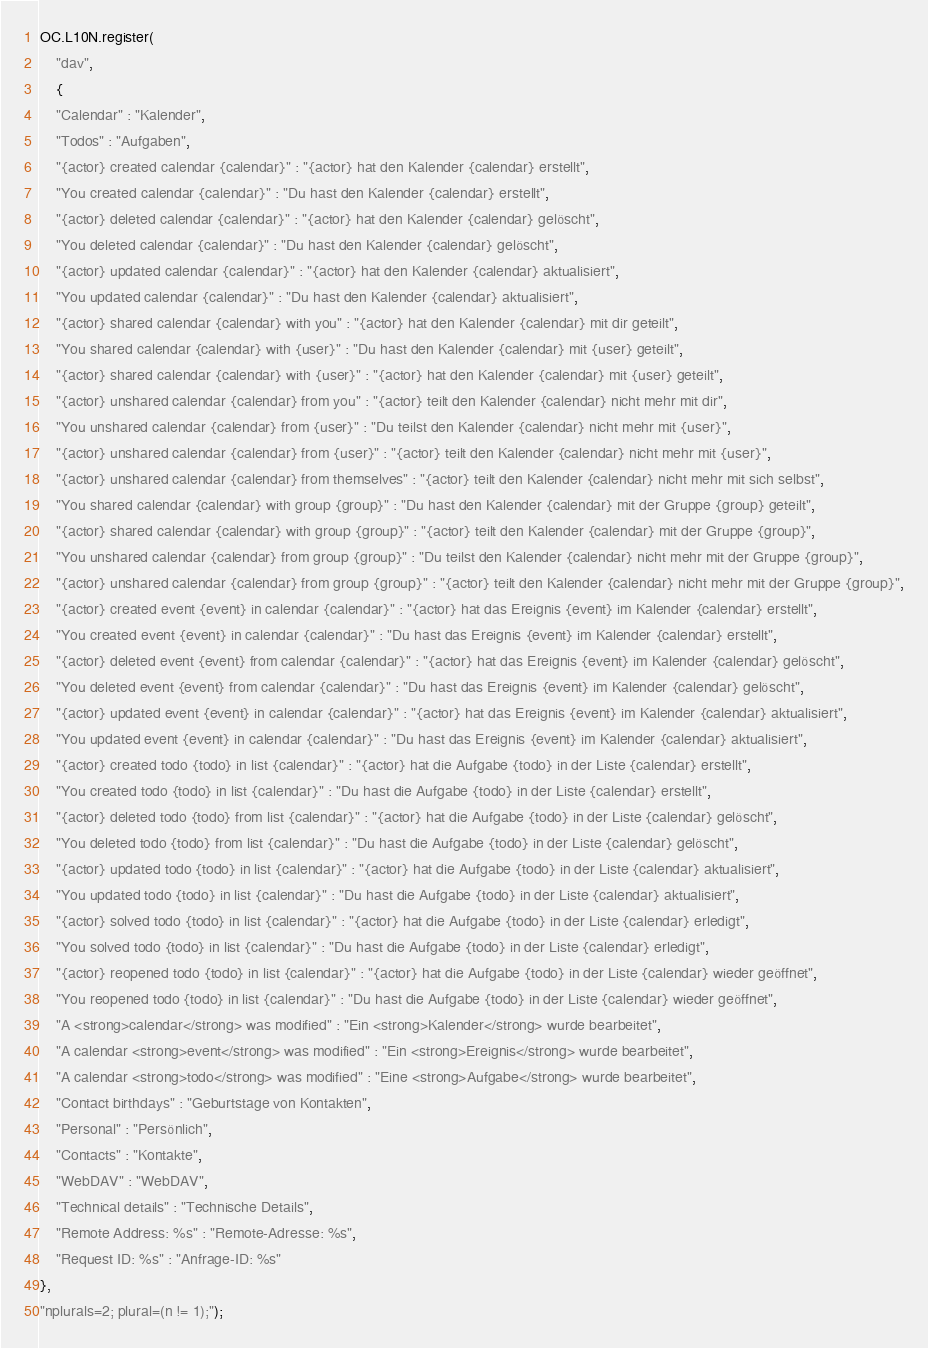<code> <loc_0><loc_0><loc_500><loc_500><_JavaScript_>OC.L10N.register(
    "dav",
    {
    "Calendar" : "Kalender",
    "Todos" : "Aufgaben",
    "{actor} created calendar {calendar}" : "{actor} hat den Kalender {calendar} erstellt",
    "You created calendar {calendar}" : "Du hast den Kalender {calendar} erstellt",
    "{actor} deleted calendar {calendar}" : "{actor} hat den Kalender {calendar} gelöscht",
    "You deleted calendar {calendar}" : "Du hast den Kalender {calendar} gelöscht",
    "{actor} updated calendar {calendar}" : "{actor} hat den Kalender {calendar} aktualisiert",
    "You updated calendar {calendar}" : "Du hast den Kalender {calendar} aktualisiert",
    "{actor} shared calendar {calendar} with you" : "{actor} hat den Kalender {calendar} mit dir geteilt",
    "You shared calendar {calendar} with {user}" : "Du hast den Kalender {calendar} mit {user} geteilt",
    "{actor} shared calendar {calendar} with {user}" : "{actor} hat den Kalender {calendar} mit {user} geteilt",
    "{actor} unshared calendar {calendar} from you" : "{actor} teilt den Kalender {calendar} nicht mehr mit dir",
    "You unshared calendar {calendar} from {user}" : "Du teilst den Kalender {calendar} nicht mehr mit {user}",
    "{actor} unshared calendar {calendar} from {user}" : "{actor} teilt den Kalender {calendar} nicht mehr mit {user}",
    "{actor} unshared calendar {calendar} from themselves" : "{actor} teilt den Kalender {calendar} nicht mehr mit sich selbst",
    "You shared calendar {calendar} with group {group}" : "Du hast den Kalender {calendar} mit der Gruppe {group} geteilt",
    "{actor} shared calendar {calendar} with group {group}" : "{actor} teilt den Kalender {calendar} mit der Gruppe {group}",
    "You unshared calendar {calendar} from group {group}" : "Du teilst den Kalender {calendar} nicht mehr mit der Gruppe {group}",
    "{actor} unshared calendar {calendar} from group {group}" : "{actor} teilt den Kalender {calendar} nicht mehr mit der Gruppe {group}",
    "{actor} created event {event} in calendar {calendar}" : "{actor} hat das Ereignis {event} im Kalender {calendar} erstellt",
    "You created event {event} in calendar {calendar}" : "Du hast das Ereignis {event} im Kalender {calendar} erstellt",
    "{actor} deleted event {event} from calendar {calendar}" : "{actor} hat das Ereignis {event} im Kalender {calendar} gelöscht",
    "You deleted event {event} from calendar {calendar}" : "Du hast das Ereignis {event} im Kalender {calendar} gelöscht",
    "{actor} updated event {event} in calendar {calendar}" : "{actor} hat das Ereignis {event} im Kalender {calendar} aktualisiert",
    "You updated event {event} in calendar {calendar}" : "Du hast das Ereignis {event} im Kalender {calendar} aktualisiert",
    "{actor} created todo {todo} in list {calendar}" : "{actor} hat die Aufgabe {todo} in der Liste {calendar} erstellt",
    "You created todo {todo} in list {calendar}" : "Du hast die Aufgabe {todo} in der Liste {calendar} erstellt",
    "{actor} deleted todo {todo} from list {calendar}" : "{actor} hat die Aufgabe {todo} in der Liste {calendar} gelöscht",
    "You deleted todo {todo} from list {calendar}" : "Du hast die Aufgabe {todo} in der Liste {calendar} gelöscht",
    "{actor} updated todo {todo} in list {calendar}" : "{actor} hat die Aufgabe {todo} in der Liste {calendar} aktualisiert",
    "You updated todo {todo} in list {calendar}" : "Du hast die Aufgabe {todo} in der Liste {calendar} aktualisiert",
    "{actor} solved todo {todo} in list {calendar}" : "{actor} hat die Aufgabe {todo} in der Liste {calendar} erledigt",
    "You solved todo {todo} in list {calendar}" : "Du hast die Aufgabe {todo} in der Liste {calendar} erledigt",
    "{actor} reopened todo {todo} in list {calendar}" : "{actor} hat die Aufgabe {todo} in der Liste {calendar} wieder geöffnet",
    "You reopened todo {todo} in list {calendar}" : "Du hast die Aufgabe {todo} in der Liste {calendar} wieder geöffnet",
    "A <strong>calendar</strong> was modified" : "Ein <strong>Kalender</strong> wurde bearbeitet",
    "A calendar <strong>event</strong> was modified" : "Ein <strong>Ereignis</strong> wurde bearbeitet",
    "A calendar <strong>todo</strong> was modified" : "Eine <strong>Aufgabe</strong> wurde bearbeitet",
    "Contact birthdays" : "Geburtstage von Kontakten",
    "Personal" : "Persönlich",
    "Contacts" : "Kontakte",
    "WebDAV" : "WebDAV",
    "Technical details" : "Technische Details",
    "Remote Address: %s" : "Remote-Adresse: %s",
    "Request ID: %s" : "Anfrage-ID: %s"
},
"nplurals=2; plural=(n != 1);");
</code> 